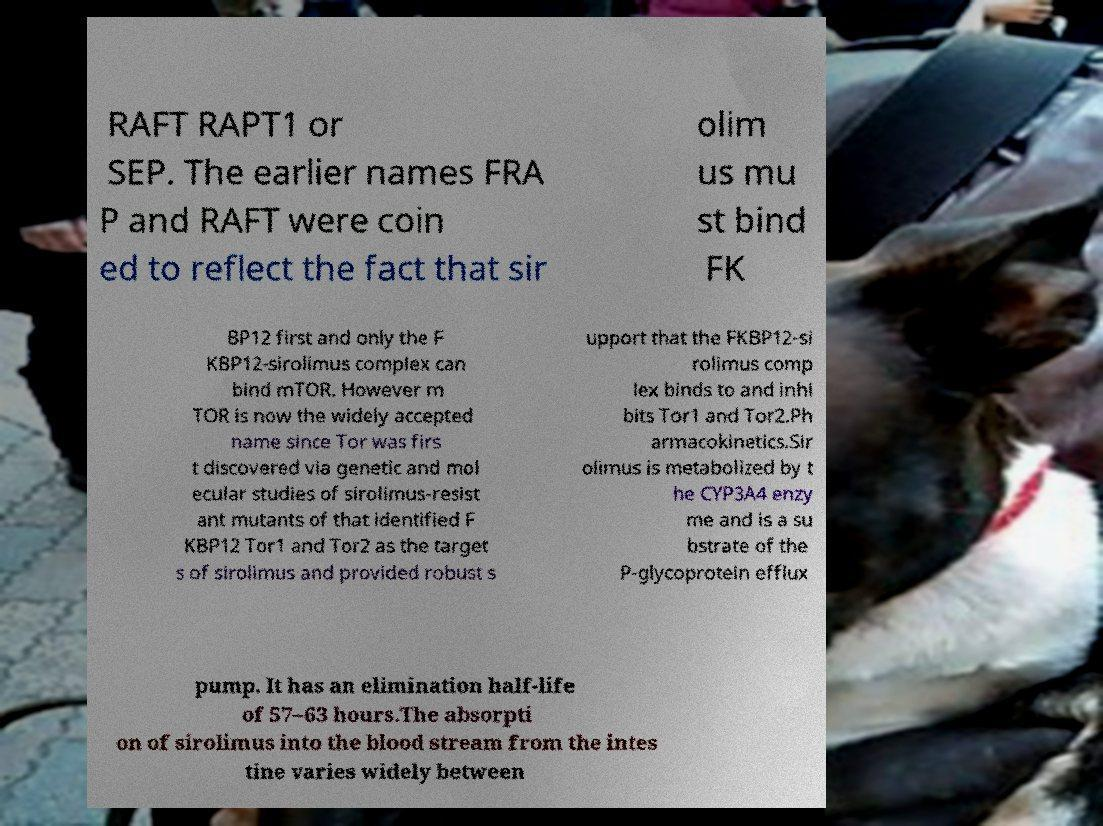For documentation purposes, I need the text within this image transcribed. Could you provide that? RAFT RAPT1 or SEP. The earlier names FRA P and RAFT were coin ed to reflect the fact that sir olim us mu st bind FK BP12 first and only the F KBP12-sirolimus complex can bind mTOR. However m TOR is now the widely accepted name since Tor was firs t discovered via genetic and mol ecular studies of sirolimus-resist ant mutants of that identified F KBP12 Tor1 and Tor2 as the target s of sirolimus and provided robust s upport that the FKBP12-si rolimus comp lex binds to and inhi bits Tor1 and Tor2.Ph armacokinetics.Sir olimus is metabolized by t he CYP3A4 enzy me and is a su bstrate of the P-glycoprotein efflux pump. It has an elimination half-life of 57–63 hours.The absorpti on of sirolimus into the blood stream from the intes tine varies widely between 